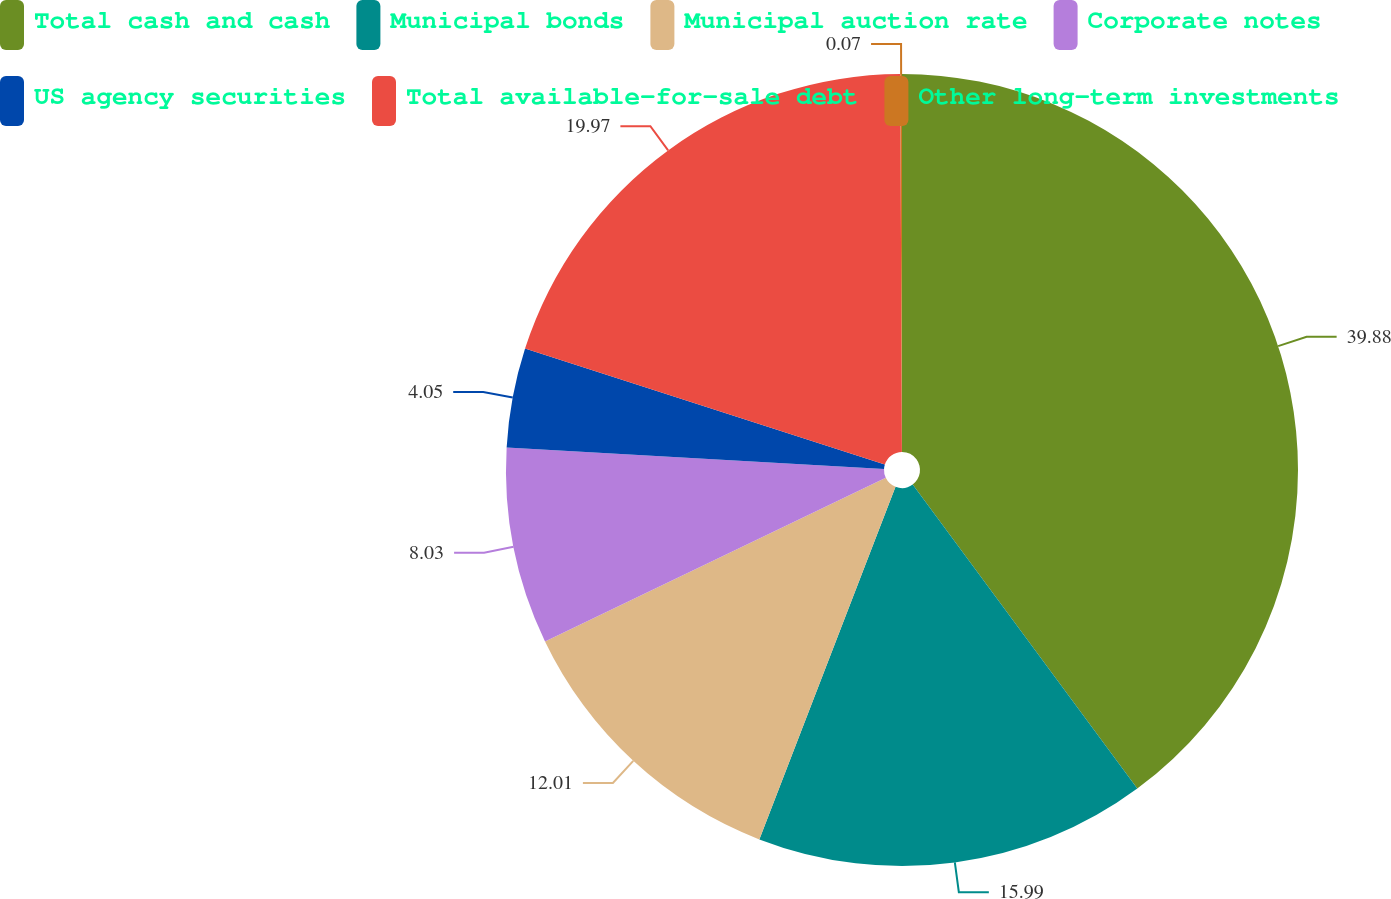Convert chart. <chart><loc_0><loc_0><loc_500><loc_500><pie_chart><fcel>Total cash and cash<fcel>Municipal bonds<fcel>Municipal auction rate<fcel>Corporate notes<fcel>US agency securities<fcel>Total available-for-sale debt<fcel>Other long-term investments<nl><fcel>39.87%<fcel>15.99%<fcel>12.01%<fcel>8.03%<fcel>4.05%<fcel>19.97%<fcel>0.07%<nl></chart> 